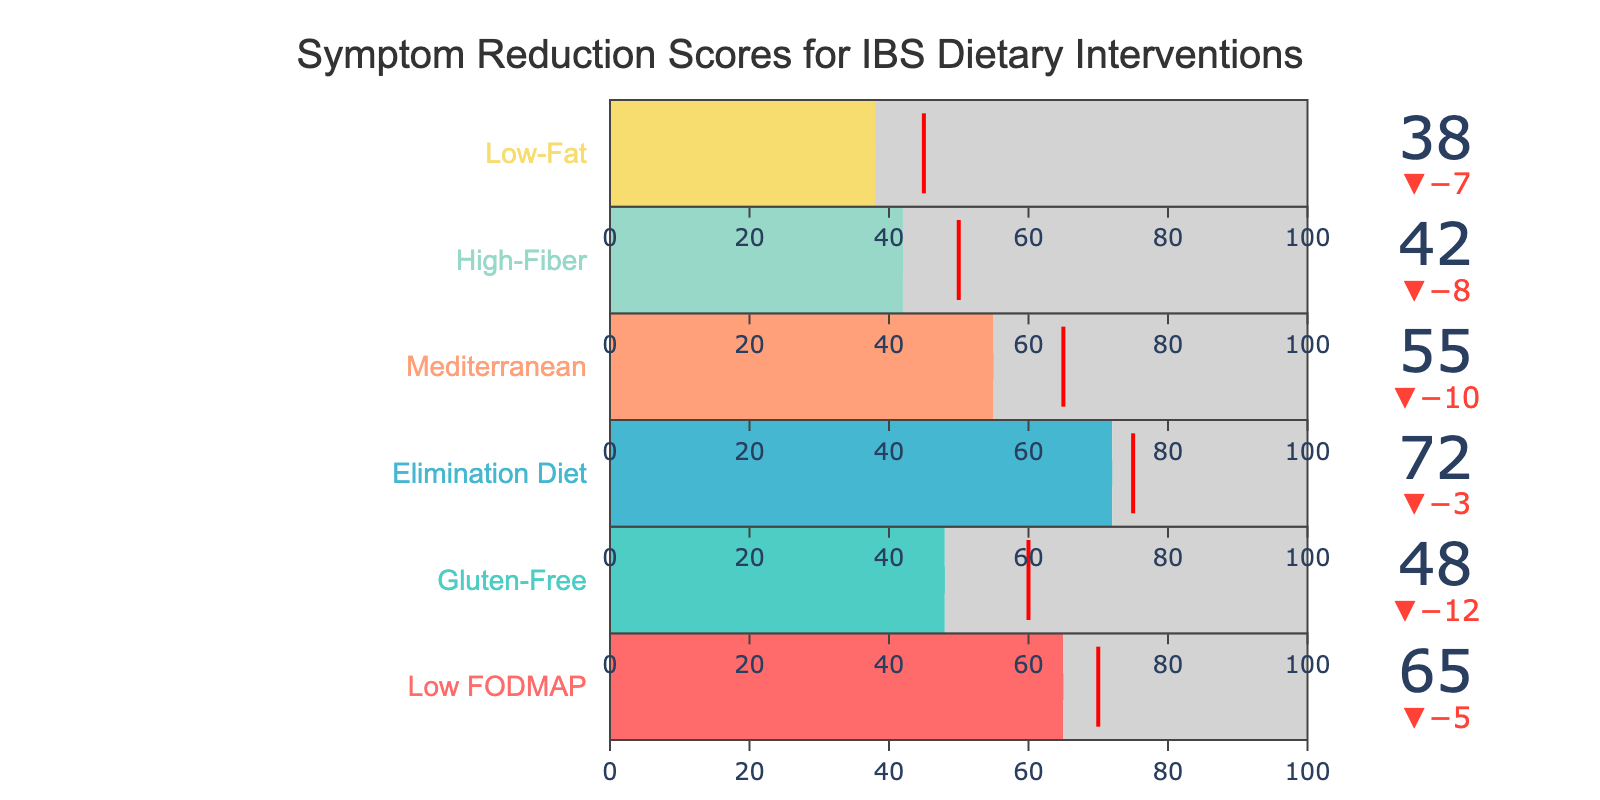What's the title of the figure? The title is displayed prominently at the top of the figure. It is "Symptom Reduction Scores for IBS Dietary Interventions".
Answer: Symptom Reduction Scores for IBS Dietary Interventions Which diet has the highest actual improvement score? By observing the bars on the chart, the Elimination Diet has the highest actual improvement score of 72.
Answer: Elimination Diet What is the target improvement score for the High-Fiber diet? The target improvement score is visually marked on the gauge for each diet type. For the High-Fiber diet, it is set at 50.
Answer: 50 Which diet type fell short the most from its target improvement score? By comparing the actual improvement values against the target improvements for each diet type, the High-Fiber diet fell short by the greatest margin, having an actual improvement of 42 against a target of 50.
Answer: High-Fiber Which diets achieved less than 50% actual improvement against their maximum potential improvement? Maximum improvement is 100 for all diets. Comparing each actual improvement with 50% of 100, the diets with improvements less than 50 are Gluten-Free (48), High-Fiber (42), and Low-Fat (38).
Answer: Gluten-Free, High-Fiber, and Low-Fat What is the difference between the actual and target improvement scores for the Mediterranean diet? By subtracting the actual score (55) from the target score (65), we find a difference of 10.
Answer: 10 How many diets exceeded their target improvement scores? By counting the diets where the actual improvement score surpasses the target improvement score, only the Elimination Diet (72) exceeds its target of 75.
Answer: 1 diet Among the listed diets, which one has the closest actual improvement to its target improvement? By observing the actual and target improvement scores, the Low-Fat diet has an actual score of 38 and a target score of 45, giving it a difference of 7, which is closer than other diet types.
Answer: Low-Fat Which diet has the lowest actual improvement and how far is it from the maximum improvement? The Low-Fat diet has the lowest actual improvement of 38. Subtracting this from the maximum improvement of 100 gives a difference of 62.
Answer: Low-Fat, 62 